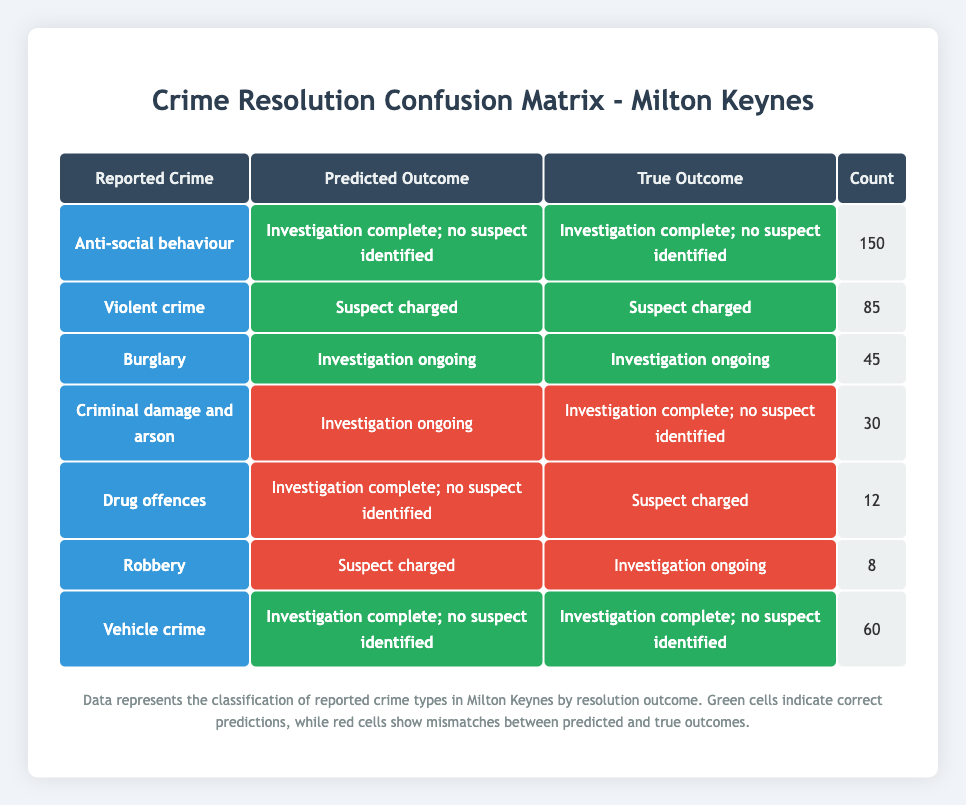What is the total number of reported crimes classified as "Violent crime"? The table shows that there are 85 reported crimes classified as "Violent crime". This number is directly listed in the count column next to the respective crime type in the table.
Answer: 85 What is the predicted outcome for "Drug offences"? According to the table, the predicted outcome for "Drug offences" is "Investigation complete; no suspect identified". This can be found in the corresponding row under the predicted outcome column.
Answer: Investigation complete; no suspect identified How many crimes in the category "Criminal damage and arson" had mismatched predictions? There are 30 reported crimes in the "Criminal damage and arson" category. The predicted outcome differs from the true outcome, indicating a mismatch. This is evident from the respective row where the true outcome is "Investigation complete; no suspect identified" and the predicted outcome is "Investigation ongoing".
Answer: 30 Is it true that "Vehicle crime" has the highest number of correct predictions? Yes, it is true. "Vehicle crime" has 60 correct predictions, evidenced by the count listed next to it, and this is the highest count among the crime types with correct predictions in the table.
Answer: Yes What is the overall count of mismatches in predicted outcomes for crimes? To find the total count of mismatches, we consider rows where predicted and true outcomes differ. The mismatches are for "Criminal damage and arson" (30), "Drug offences" (12), and "Robbery" (8), so we sum these counts: 30 + 12 + 8 = 50. Thus, the overall count of mismatches is 50.
Answer: 50 Which crime type has the least number of reports and what is its predicted outcome? The "Robbery" category has the least number of reports with a total of 8. Its predicted outcome is "Suspect charged," as indicated in the corresponding row in the table.
Answer: Robbery, Suspect charged What percentage of "Anti-social behaviour" reports resulted in a correct prediction? There are 150 reports of "Anti-social behaviour" and all resulted in a correct prediction as shown in the table. Therefore, the percentage of correct predictions is (150/150) * 100 = 100%.
Answer: 100% Compare the number of reports for "Burglary" and "Robbery". What is the difference? "Burglary" has 45 reports while "Robbery" has 8 reports. To find the difference, we subtract the number of robbery reports from burglary reports: 45 - 8 = 37.
Answer: 37 How many total predicted outcomes are classified as "Investigation ongoing"? Looking at the table, the crime types that have predicted outcomes as "Investigation ongoing" are "Burglary" (45) and "Criminal damage and arson" (30), and "Robbery" (8). Therefore, the total is 45 + 30 + 8 = 83.
Answer: 83 